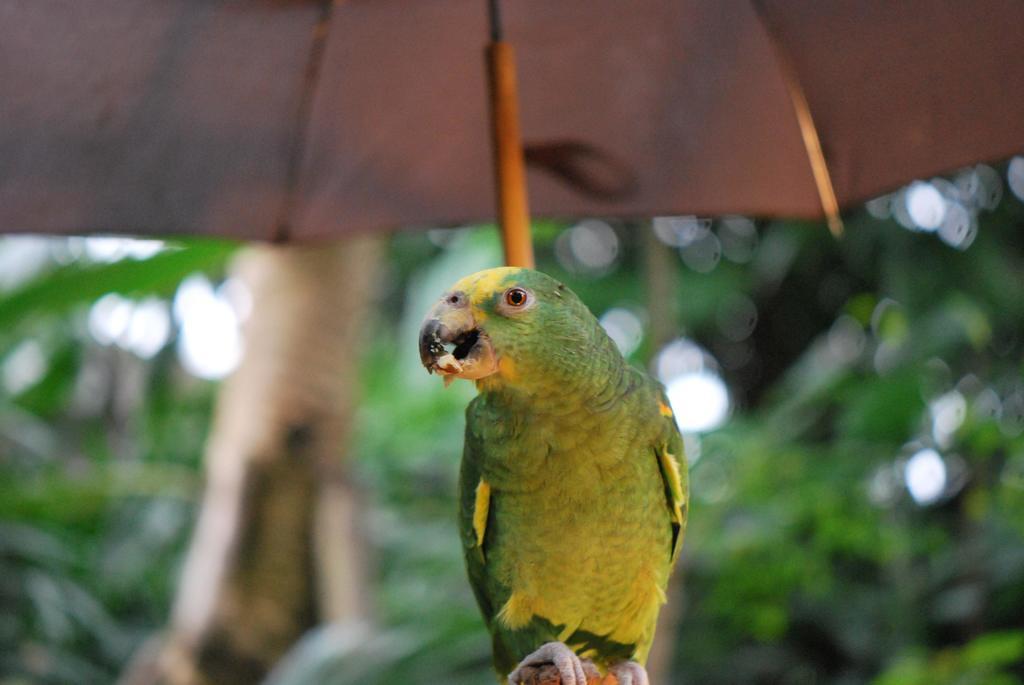In one or two sentences, can you explain what this image depicts? In this picture we can see a parrot and an umbrella. In the background of the image it is blurry. 